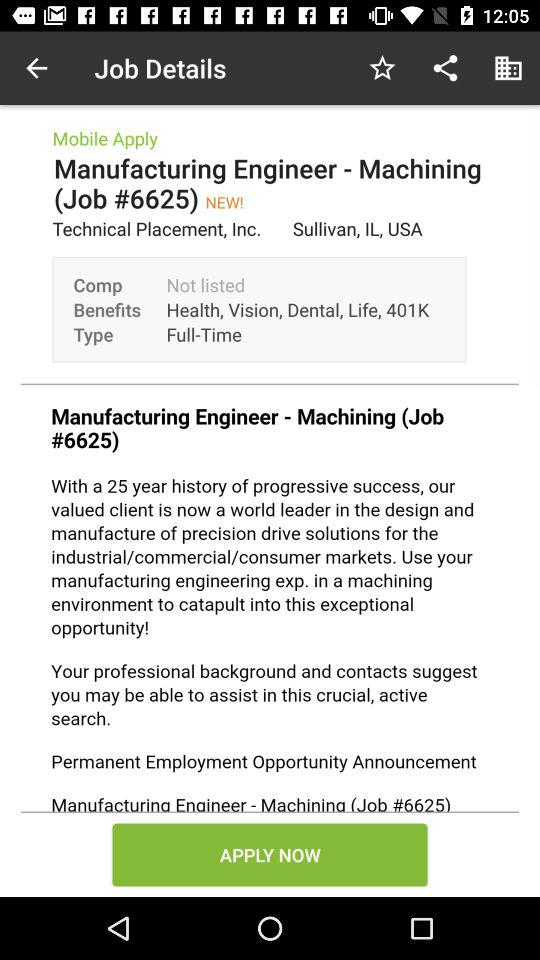What are the benefits of the job? The benefits are "Health", "Vision", "Dental", "Life" and "401K". 